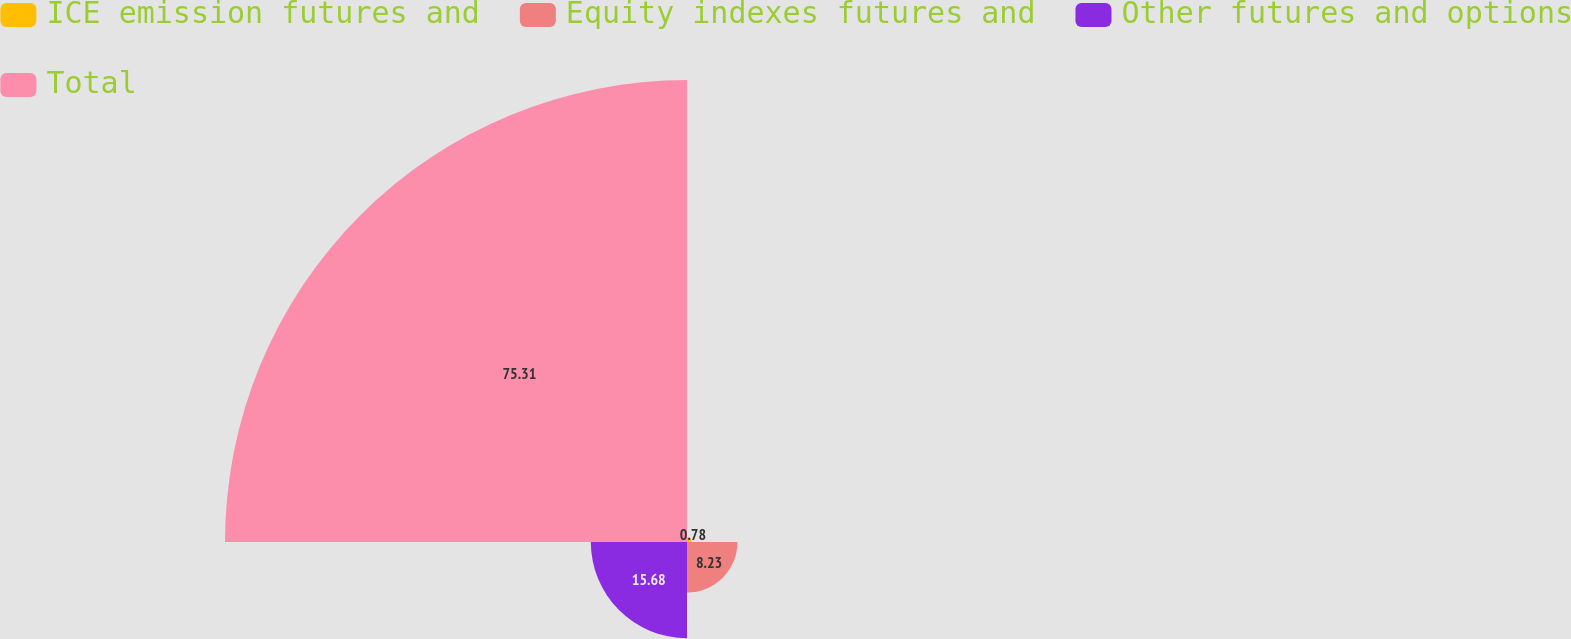Convert chart. <chart><loc_0><loc_0><loc_500><loc_500><pie_chart><fcel>ICE emission futures and<fcel>Equity indexes futures and<fcel>Other futures and options<fcel>Total<nl><fcel>0.78%<fcel>8.23%<fcel>15.68%<fcel>75.3%<nl></chart> 